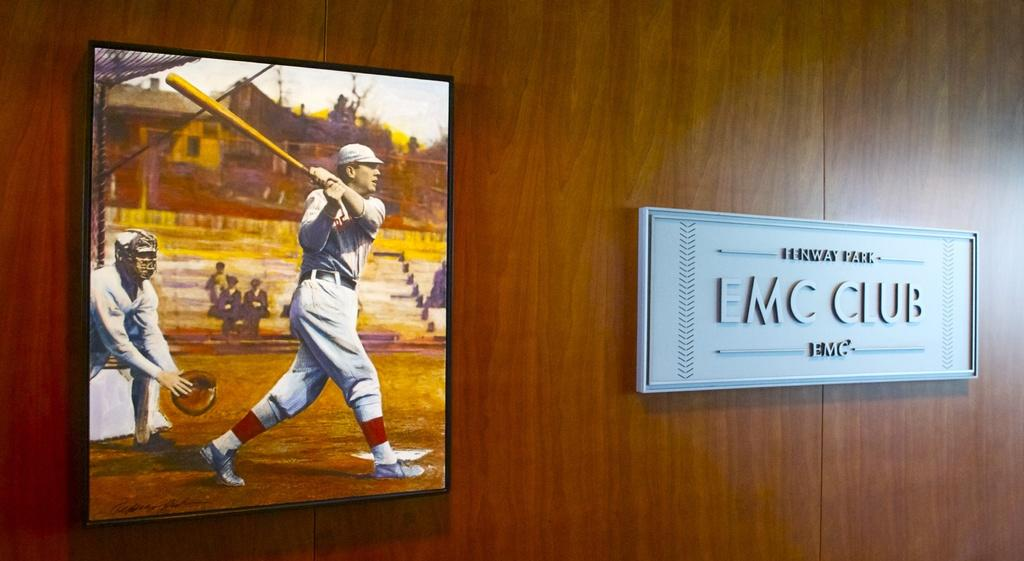What is one object visible in the image? There is a photo frame in the image. What is another object visible in the image? There is a name board in the image. Where are the photo frame and name board located? Both the photo frame and name board are on a wooden surface. What type of agreement is depicted in the image? There is no agreement depicted in the image; it features a photo frame and name board on a wooden surface. What color is the copper board in the image? There is no copper board present in the image. 